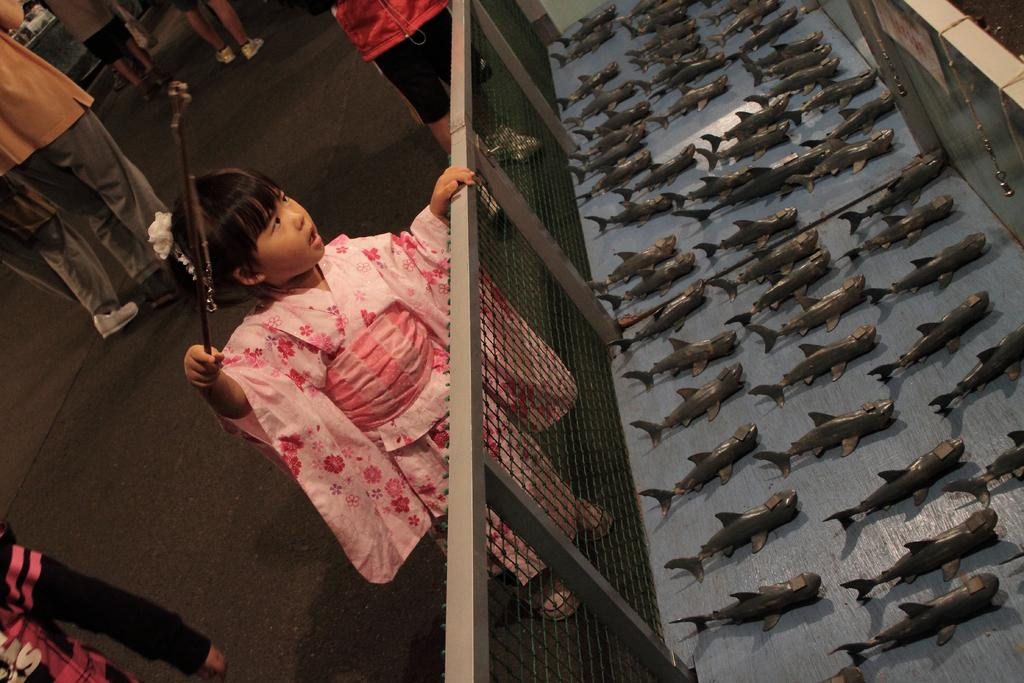What is the girl in the image doing? The girl is standing in the image and holding a fishing rod. What can be seen in the girl's hands? The girl is holding a fishing rod. What is present in the image that might be used for catching fish? There is a mesh in the image. How many fishes are visible in the image? There are fishes in the image. Can you describe the people in the image? There are people in the image. What can be seen in the background of the image? There are objects on a platform in the background of the image. Where is the bulb located in the image? There is no bulb present in the image. What type of playground equipment can be seen in the image? There is no playground equipment present in the image. 